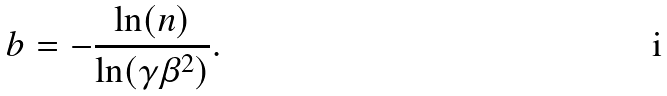<formula> <loc_0><loc_0><loc_500><loc_500>b = - \frac { \ln ( n ) } { \ln ( \gamma \beta ^ { 2 } ) } .</formula> 